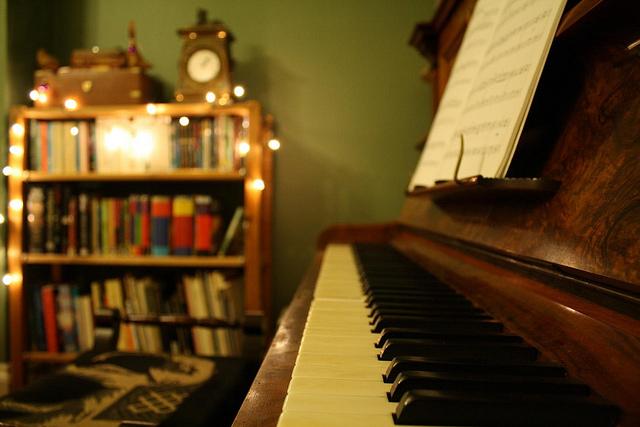Where is the clock?
Give a very brief answer. On bookshelf. Where are these benches at?
Quick response, please. Front of piano. What is the instrument?
Short answer required. Piano. Is that a bookshelf?
Keep it brief. Yes. 